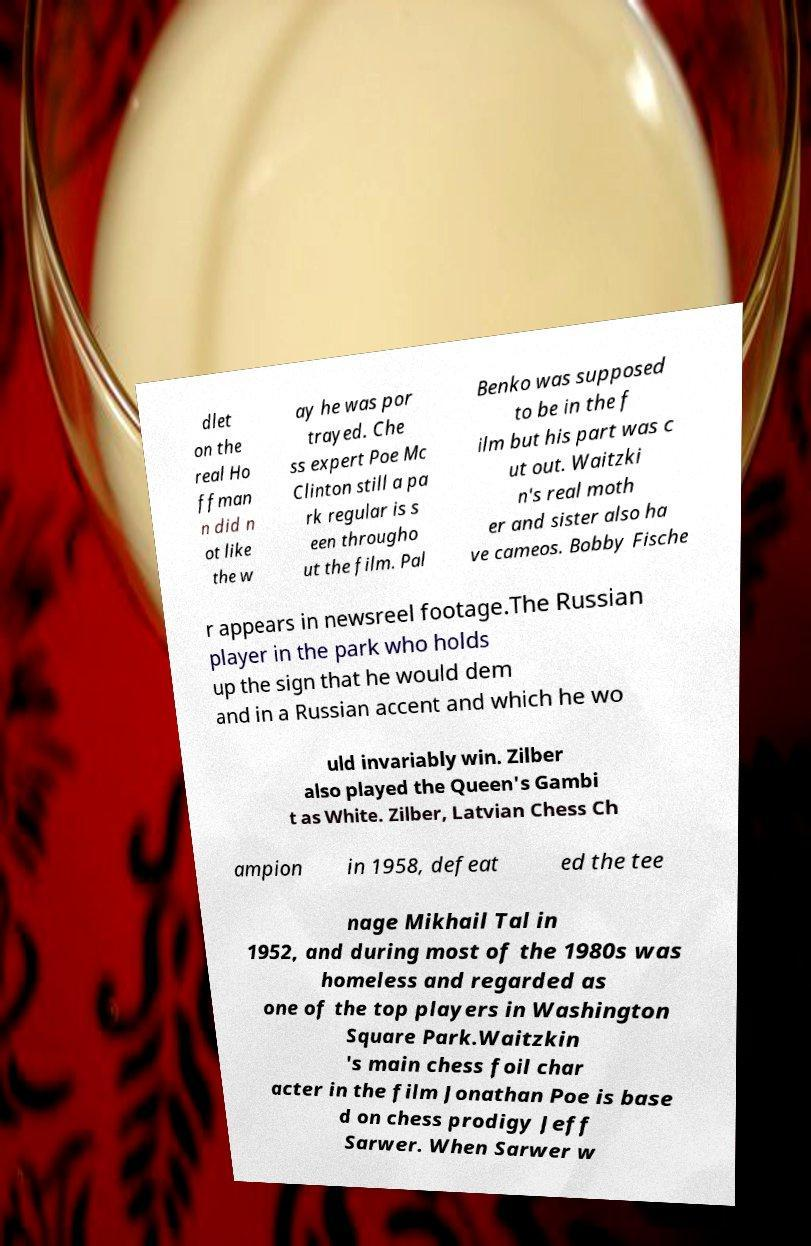There's text embedded in this image that I need extracted. Can you transcribe it verbatim? dlet on the real Ho ffman n did n ot like the w ay he was por trayed. Che ss expert Poe Mc Clinton still a pa rk regular is s een througho ut the film. Pal Benko was supposed to be in the f ilm but his part was c ut out. Waitzki n's real moth er and sister also ha ve cameos. Bobby Fische r appears in newsreel footage.The Russian player in the park who holds up the sign that he would dem and in a Russian accent and which he wo uld invariably win. Zilber also played the Queen's Gambi t as White. Zilber, Latvian Chess Ch ampion in 1958, defeat ed the tee nage Mikhail Tal in 1952, and during most of the 1980s was homeless and regarded as one of the top players in Washington Square Park.Waitzkin 's main chess foil char acter in the film Jonathan Poe is base d on chess prodigy Jeff Sarwer. When Sarwer w 